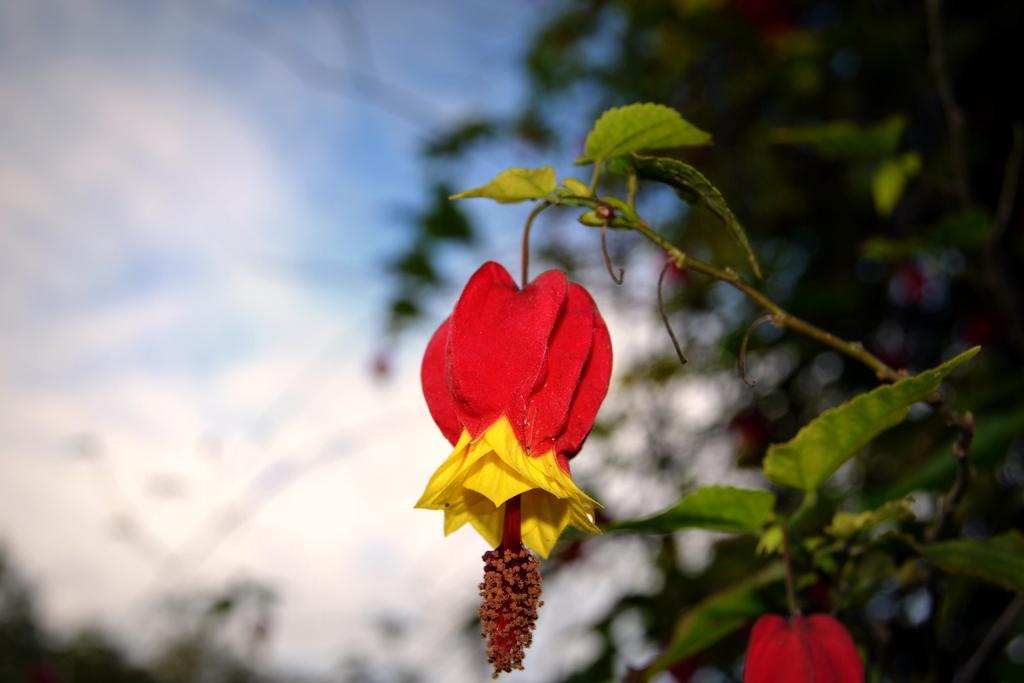How would you summarize this image in a sentence or two? In this image I can see red color flowers. In the background I can see plants. The background of the image is blurred. 